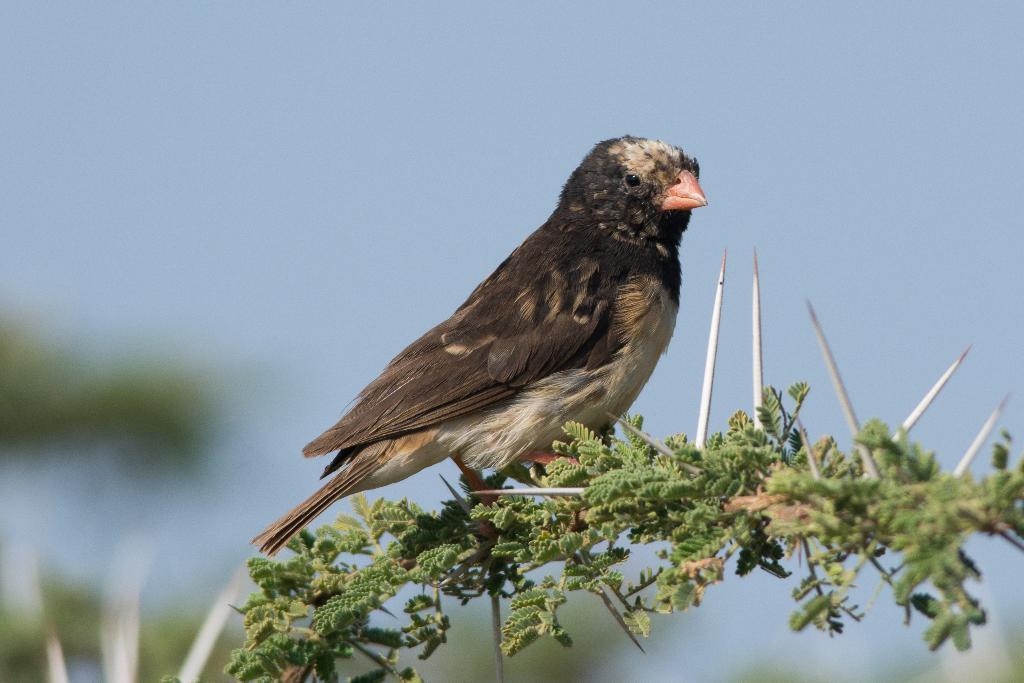What is the main subject in the center of the image? There is a bird in the center of the image. Where is the bird located? The bird is on a stem. What other plant elements can be seen in the image? There are leaves visible in the image. Are there any potentially dangerous elements in the image? Yes, there are thorns in the image. What can be seen in the background of the image? The sky is visible in the background of the image. Can you see any blood on the bird's beak in the image? There is no blood visible on the bird's beak in the image. What is the bird attempting to do in the image? The image does not show the bird attempting to do anything specific; it is simply perched on a stem. 